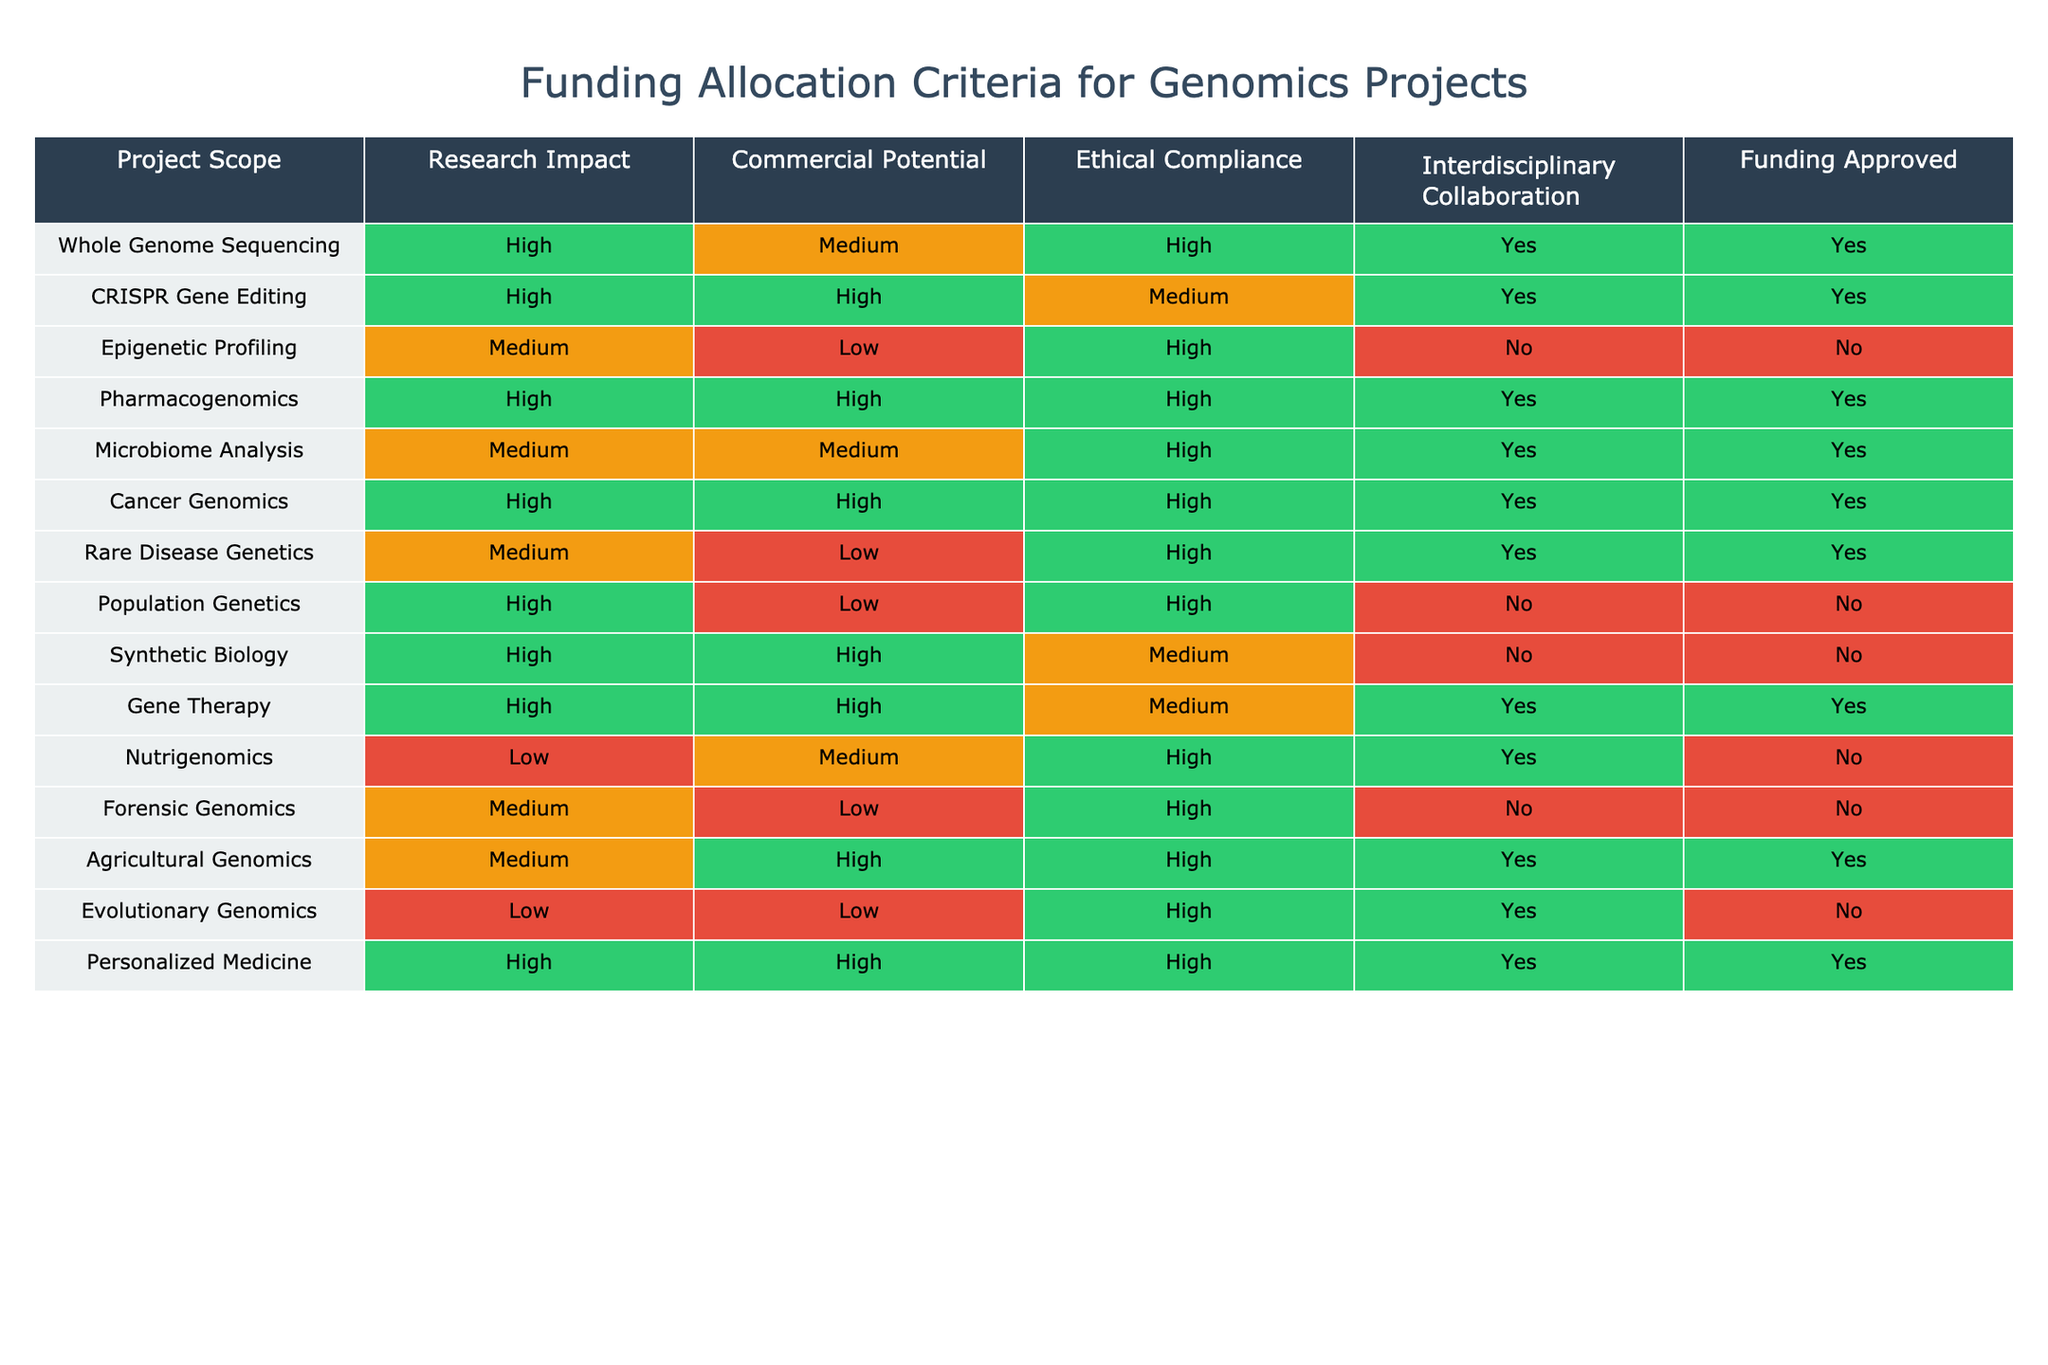What projects have received funding approval? To find the projects that received funding approval, I look for rows in the 'Funding Approved' column where the value is 'Yes'. The projects that meet this criterion are: Whole Genome Sequencing, CRISPR Gene Editing, Pharmacogenomics, Microbiome Analysis, Cancer Genomics, Rare Disease Genetics, Gene Therapy, Agricultural Genomics, and Personalized Medicine.
Answer: Whole Genome Sequencing, CRISPR Gene Editing, Pharmacogenomics, Microbiome Analysis, Cancer Genomics, Rare Disease Genetics, Gene Therapy, Agricultural Genomics, Personalized Medicine How many projects have high research impact and also received funding? First, I count the projects with 'High' in the 'Research Impact' column. Then, I filter this list to see how many of these projects also have 'Yes' in the 'Funding Approved' column. The projects with high research impact that received funding are: Whole Genome Sequencing, CRISPR Gene Editing, Pharmacogenomics, Cancer Genomics, Gene Therapy, and Personalized Medicine. That's a total of 6 projects.
Answer: 6 Is there a project with 'Low' ethical compliance that received funding? I need to check the 'Ethical Compliance' column for the value 'Low' and then cross-reference this with 'Funding Approved' for 'Yes'. The project 'Nutrigenomics' has 'Low' ethical compliance but is marked as 'No' for funding, and 'Forensic Genomics' also shows 'Low' ethical compliance with 'No' funding. Thus, no project with low ethical compliance has received funding.
Answer: No Which project has the highest commercial potential among those approved for funding? Among the projects that received funding (those with 'Yes' in 'Funding Approved'), I look at the 'Commercial Potential' column. The relevant projects are: Whole Genome Sequencing, CRISPR Gene Editing, Pharmacogenomics, Microbiome Analysis, Cancer Genomics, Rare Disease Genetics, Gene Therapy, Agricultural Genomics, and Personalized Medicine. 'Pharmacogenomics', 'Cancer Genomics', and 'Gene Therapy' all have 'High' commercial potential. However, since the question is about the highest, I conclude that it's a tie between these three projects.
Answer: Pharmacogenomics, Cancer Genomics, Gene Therapy What is the total number of projects categorized as 'Medium' regarding both research impact and commercial potential that received funding? I count how many projects fall under the 'Medium' categories in both the 'Research Impact' and 'Commercial Potential' columns while also having 'Yes' in the 'Funding Approved' column. After checking, I find that only one project, 'Microbiome Analysis', meets these criteria.
Answer: 1 